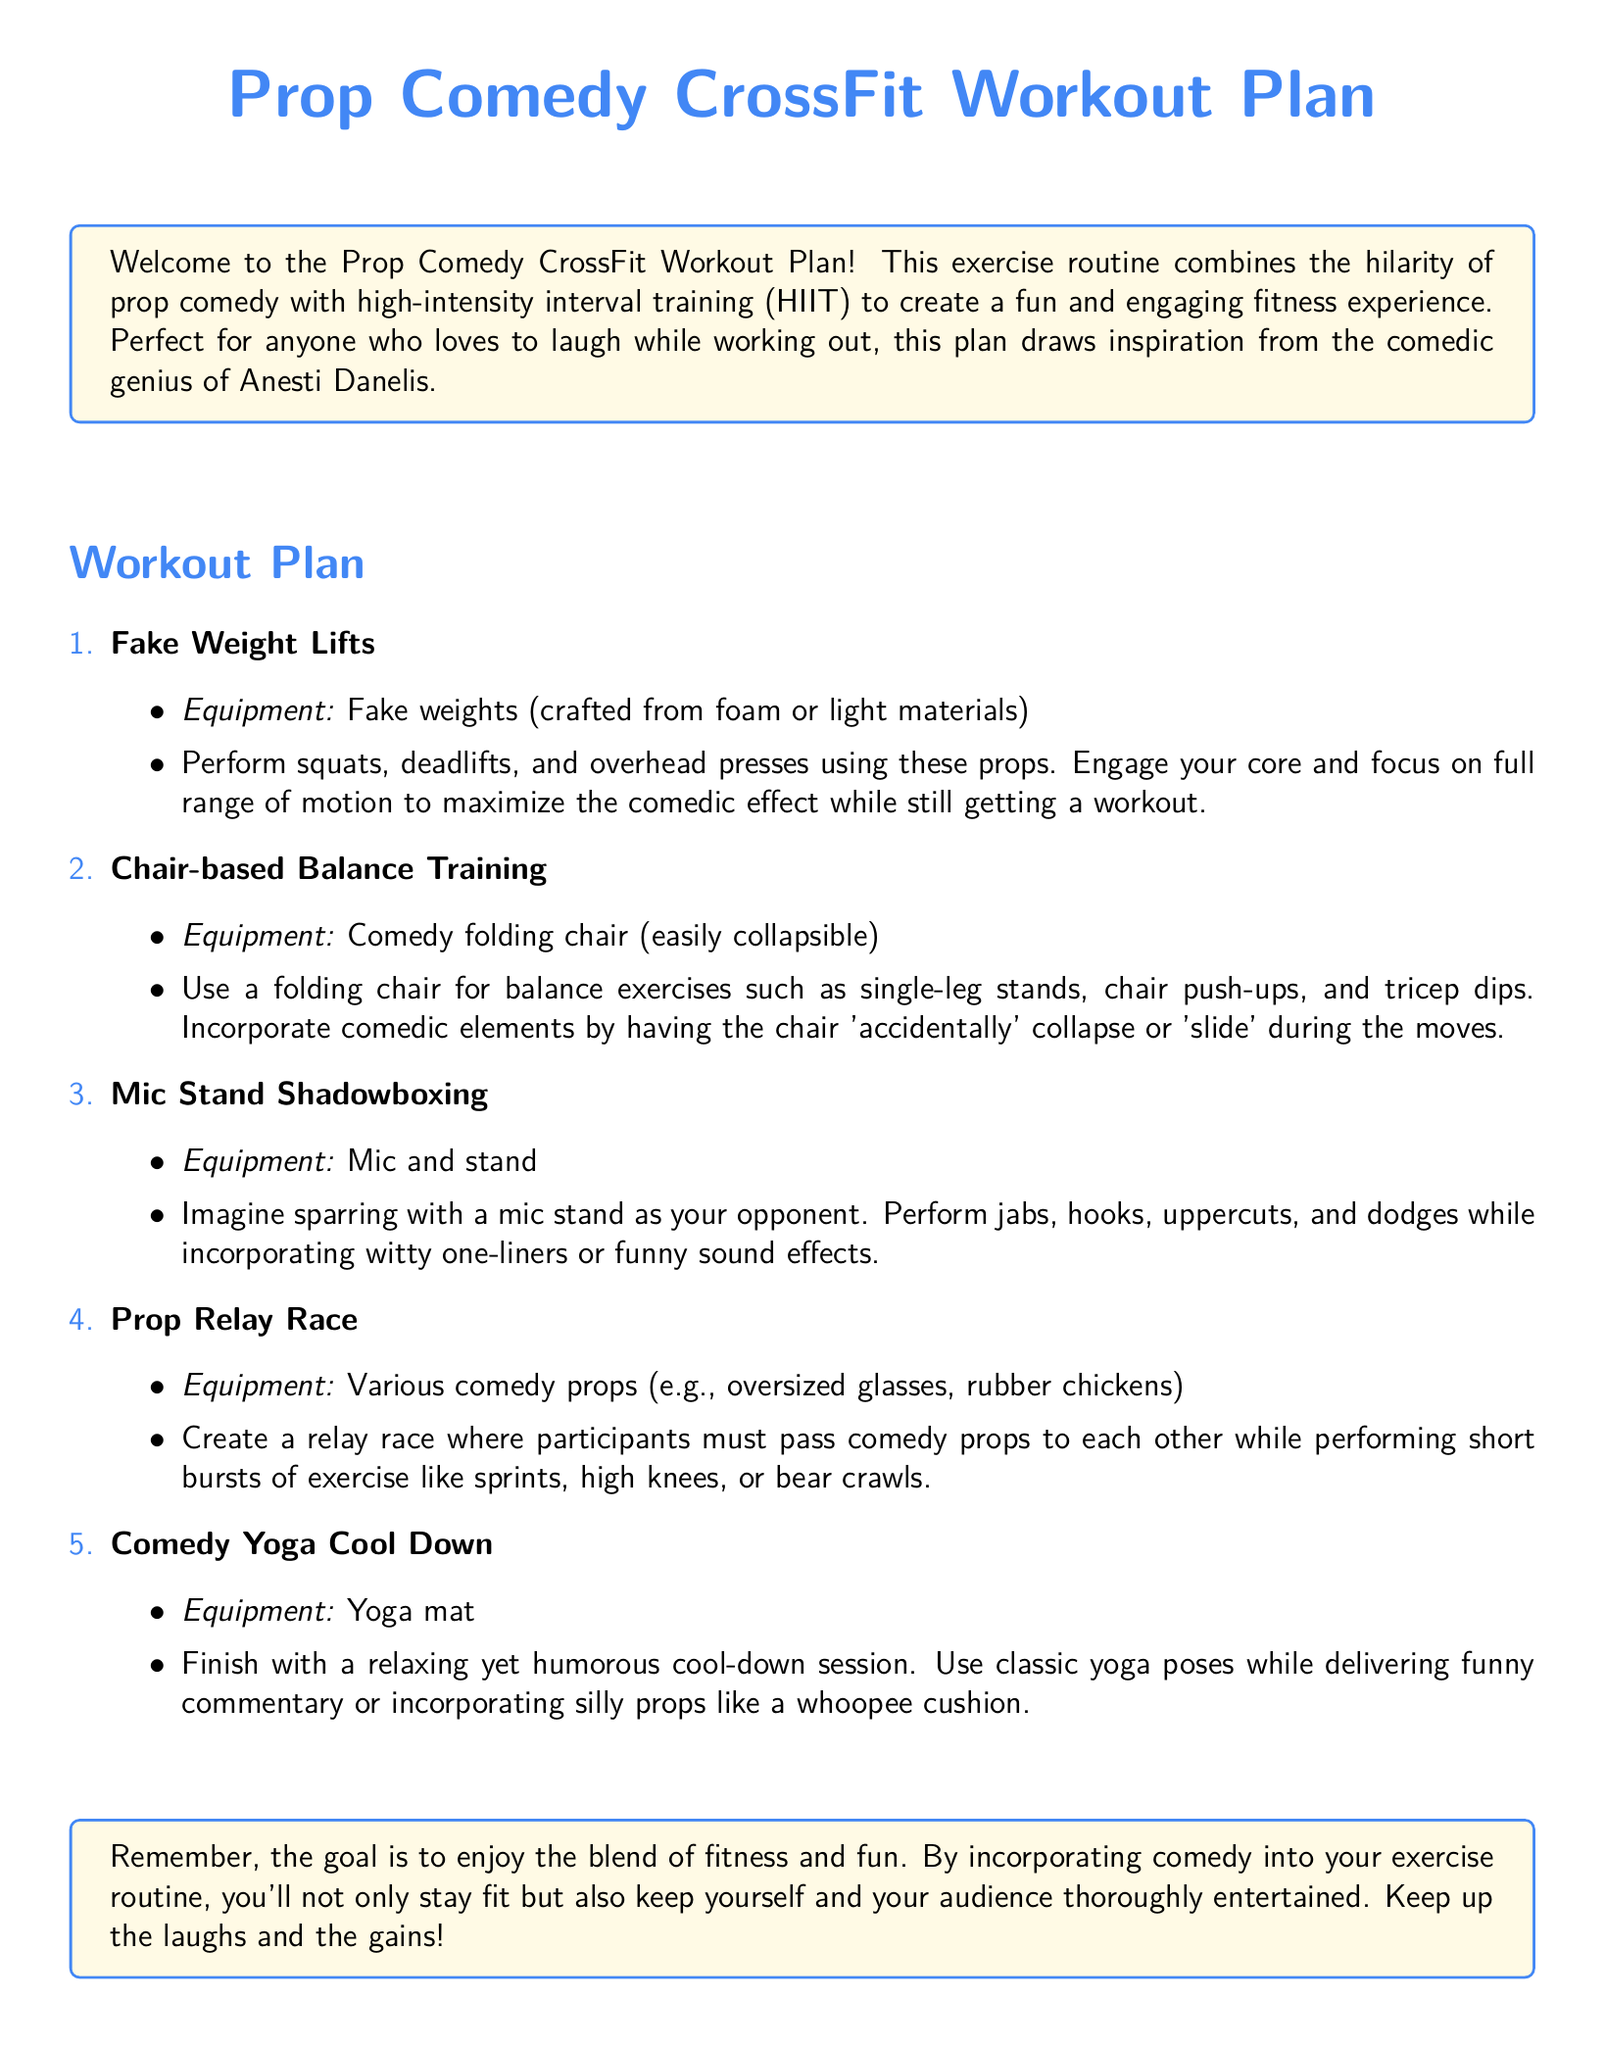What is the title of the workout plan? The title of the workout plan is provided at the beginning of the document.
Answer: Prop Comedy CrossFit Workout Plan How many exercises are listed in the workout plan? The document lists a total of five different exercises.
Answer: 5 What equipment is used for the Fake Weight Lifts? The equipment needed for the Fake Weight Lifts is specified in the exercise description.
Answer: Fake weights What is the final exercise in the workout plan? The final exercise is identified as the last point in the list.
Answer: Comedy Yoga Cool Down What added element is suggested during the Chair-based Balance Training? The document mentions a humorous element associated with the training.
Answer: Chair 'accidentally' collapses What is the main goal of the workout plan? The document outlines the main objective at the end of the introduction.
Answer: Enjoy the blend of fitness and fun What type of training does this workout combine with comedy? The workout plan specifies the style of training being utilized.
Answer: High-intensity interval training Which comedy prop is used in the Mic Stand Shadowboxing? The specific prop used for the shadowboxing exercise is mentioned in the description.
Answer: Mic stand What short exercise follows after passing comedy props in the Relay Race? The document lists exercises to perform during the relay.
Answer: Sprints 